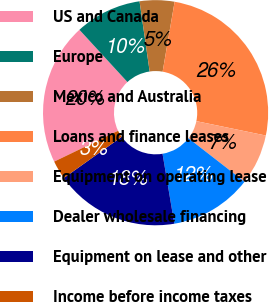Convert chart to OTSL. <chart><loc_0><loc_0><loc_500><loc_500><pie_chart><fcel>US and Canada<fcel>Europe<fcel>Mexico and Australia<fcel>Loans and finance leases<fcel>Equipment on operating lease<fcel>Dealer wholesale financing<fcel>Equipment on lease and other<fcel>Income before income taxes<nl><fcel>20.33%<fcel>9.55%<fcel>4.98%<fcel>25.55%<fcel>7.26%<fcel>11.83%<fcel>17.82%<fcel>2.69%<nl></chart> 